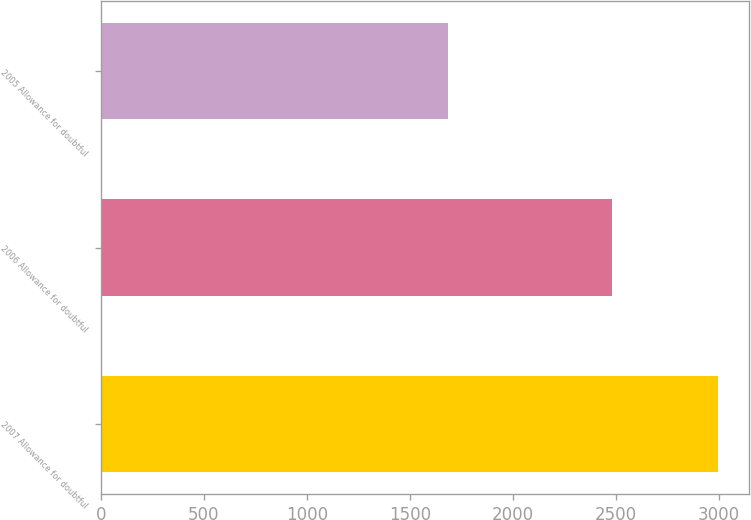Convert chart to OTSL. <chart><loc_0><loc_0><loc_500><loc_500><bar_chart><fcel>2007 Allowance for doubtful<fcel>2006 Allowance for doubtful<fcel>2005 Allowance for doubtful<nl><fcel>2998<fcel>2481<fcel>1686<nl></chart> 